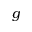Convert formula to latex. <formula><loc_0><loc_0><loc_500><loc_500>g</formula> 